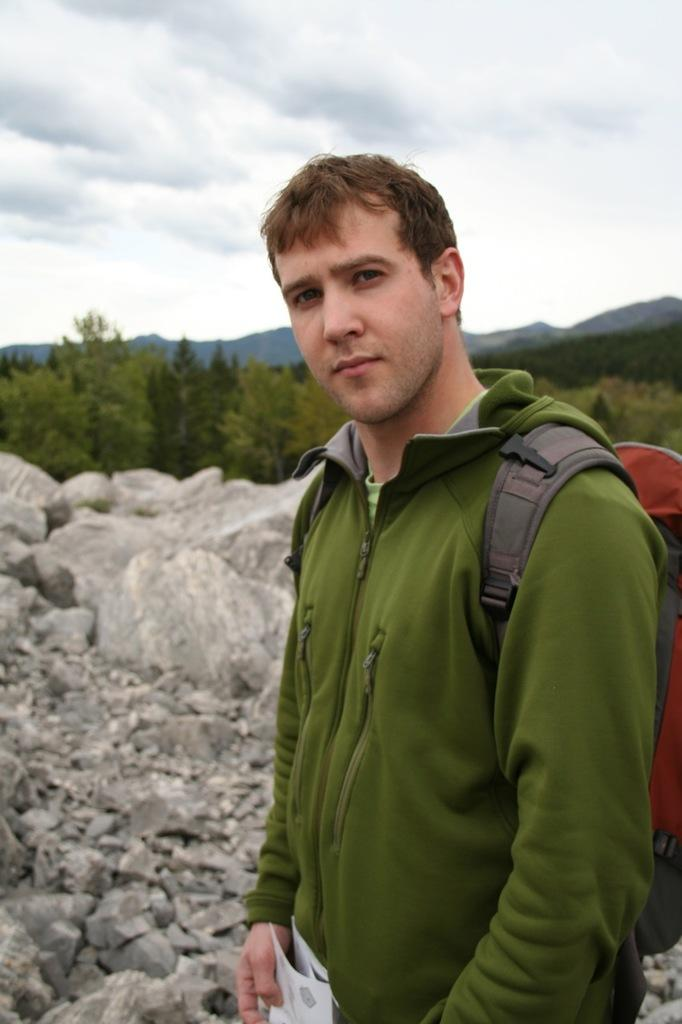Who is present in the image? There is a man in the image. What is the man wearing? The man is wearing a green jacket. What is the man standing on? The man is standing on a floor. What can be seen in the background of the image? There are trees and the sky visible in the background of the image. What type of attack is the man preparing to launch in the image? There is no indication of an attack or any aggressive action in the image; the man is simply standing on a floor. 